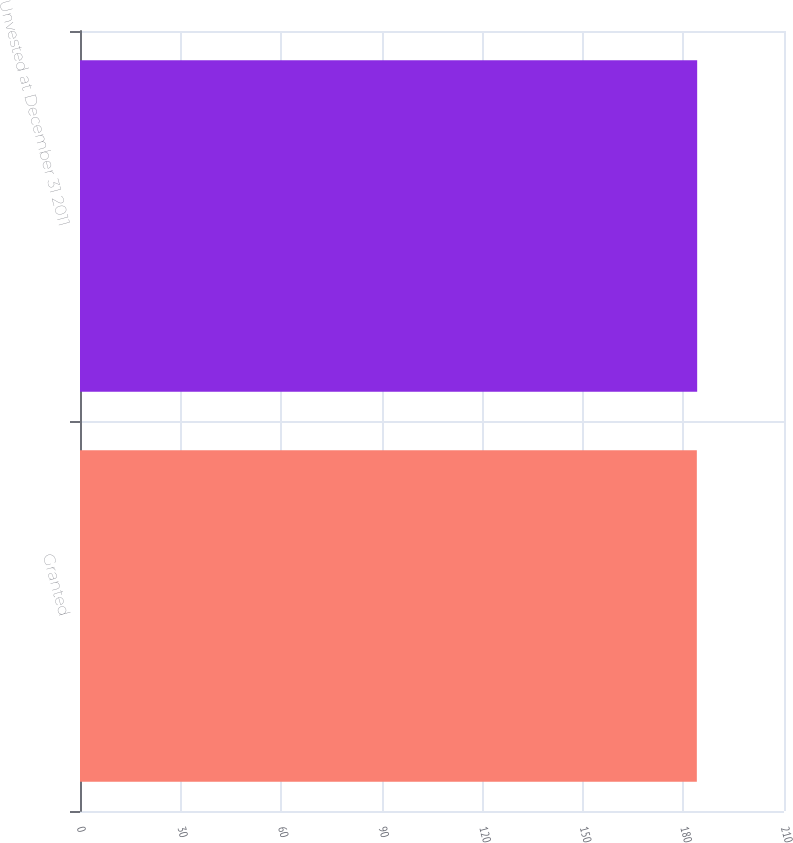<chart> <loc_0><loc_0><loc_500><loc_500><bar_chart><fcel>Granted<fcel>Unvested at December 31 2011<nl><fcel>184<fcel>184.1<nl></chart> 